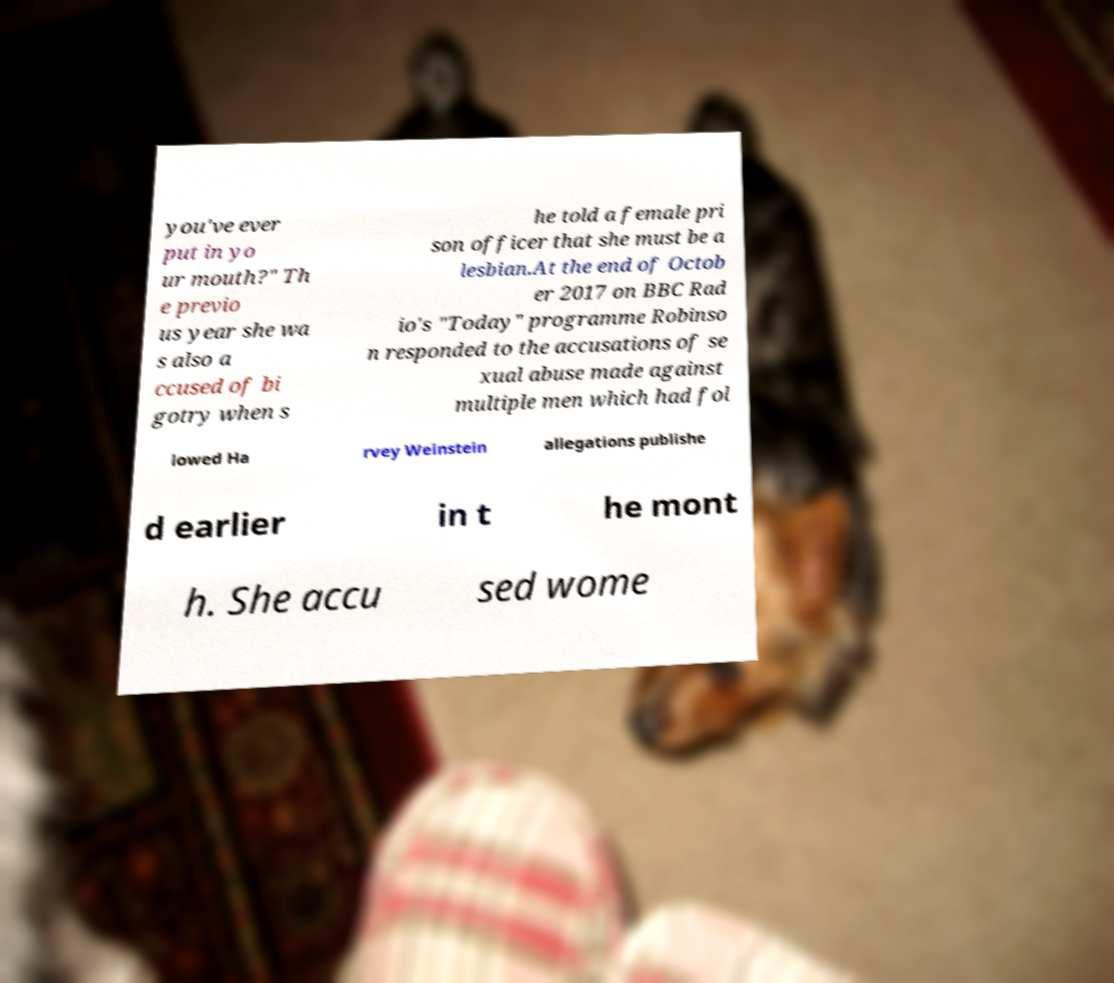Can you accurately transcribe the text from the provided image for me? you've ever put in yo ur mouth?" Th e previo us year she wa s also a ccused of bi gotry when s he told a female pri son officer that she must be a lesbian.At the end of Octob er 2017 on BBC Rad io's "Today" programme Robinso n responded to the accusations of se xual abuse made against multiple men which had fol lowed Ha rvey Weinstein allegations publishe d earlier in t he mont h. She accu sed wome 